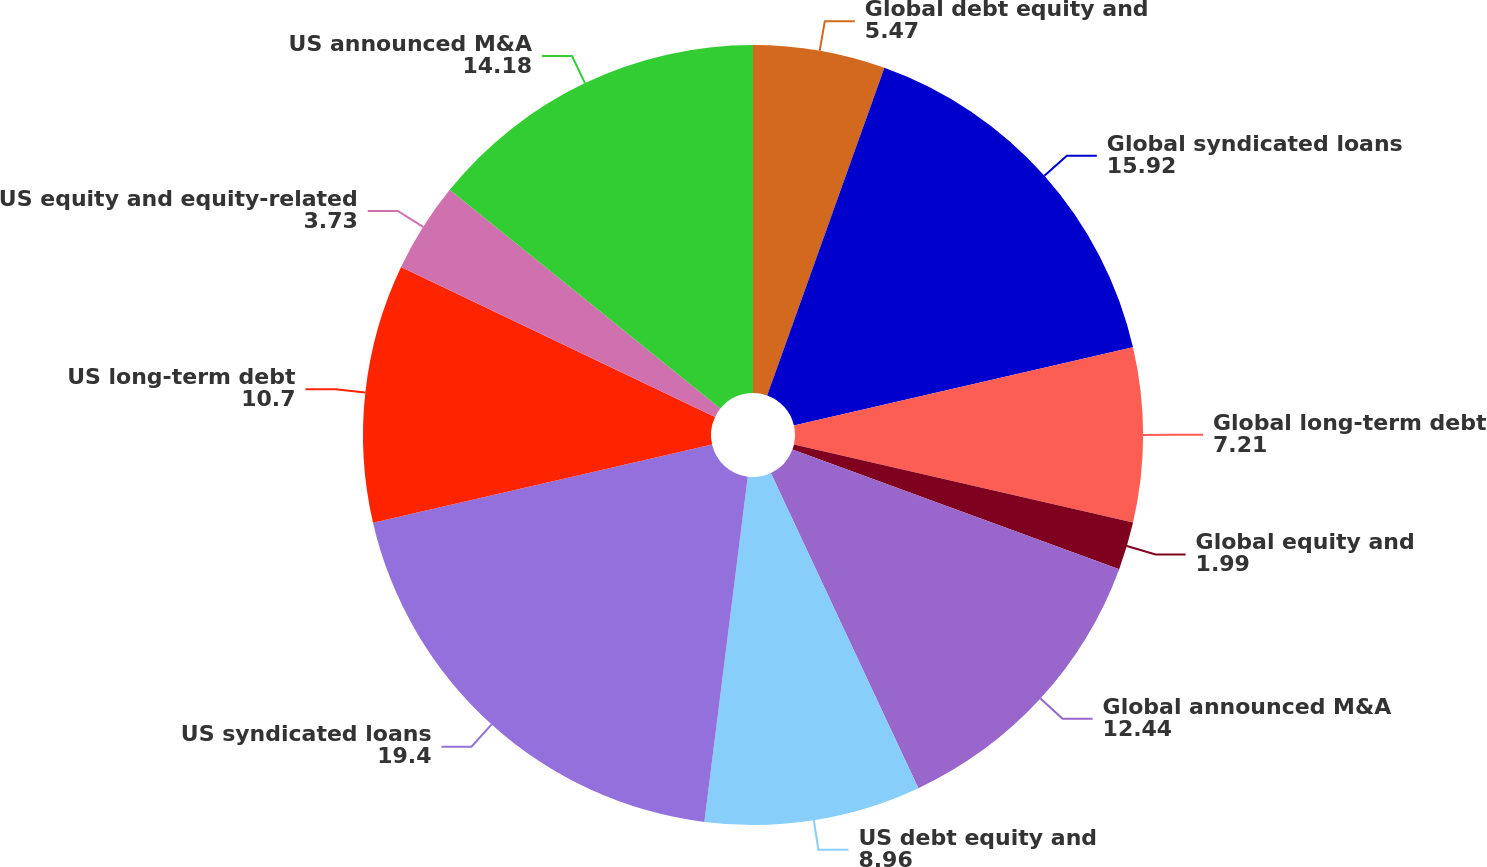<chart> <loc_0><loc_0><loc_500><loc_500><pie_chart><fcel>Global debt equity and<fcel>Global syndicated loans<fcel>Global long-term debt<fcel>Global equity and<fcel>Global announced M&A<fcel>US debt equity and<fcel>US syndicated loans<fcel>US long-term debt<fcel>US equity and equity-related<fcel>US announced M&A<nl><fcel>5.47%<fcel>15.92%<fcel>7.21%<fcel>1.99%<fcel>12.44%<fcel>8.96%<fcel>19.4%<fcel>10.7%<fcel>3.73%<fcel>14.18%<nl></chart> 